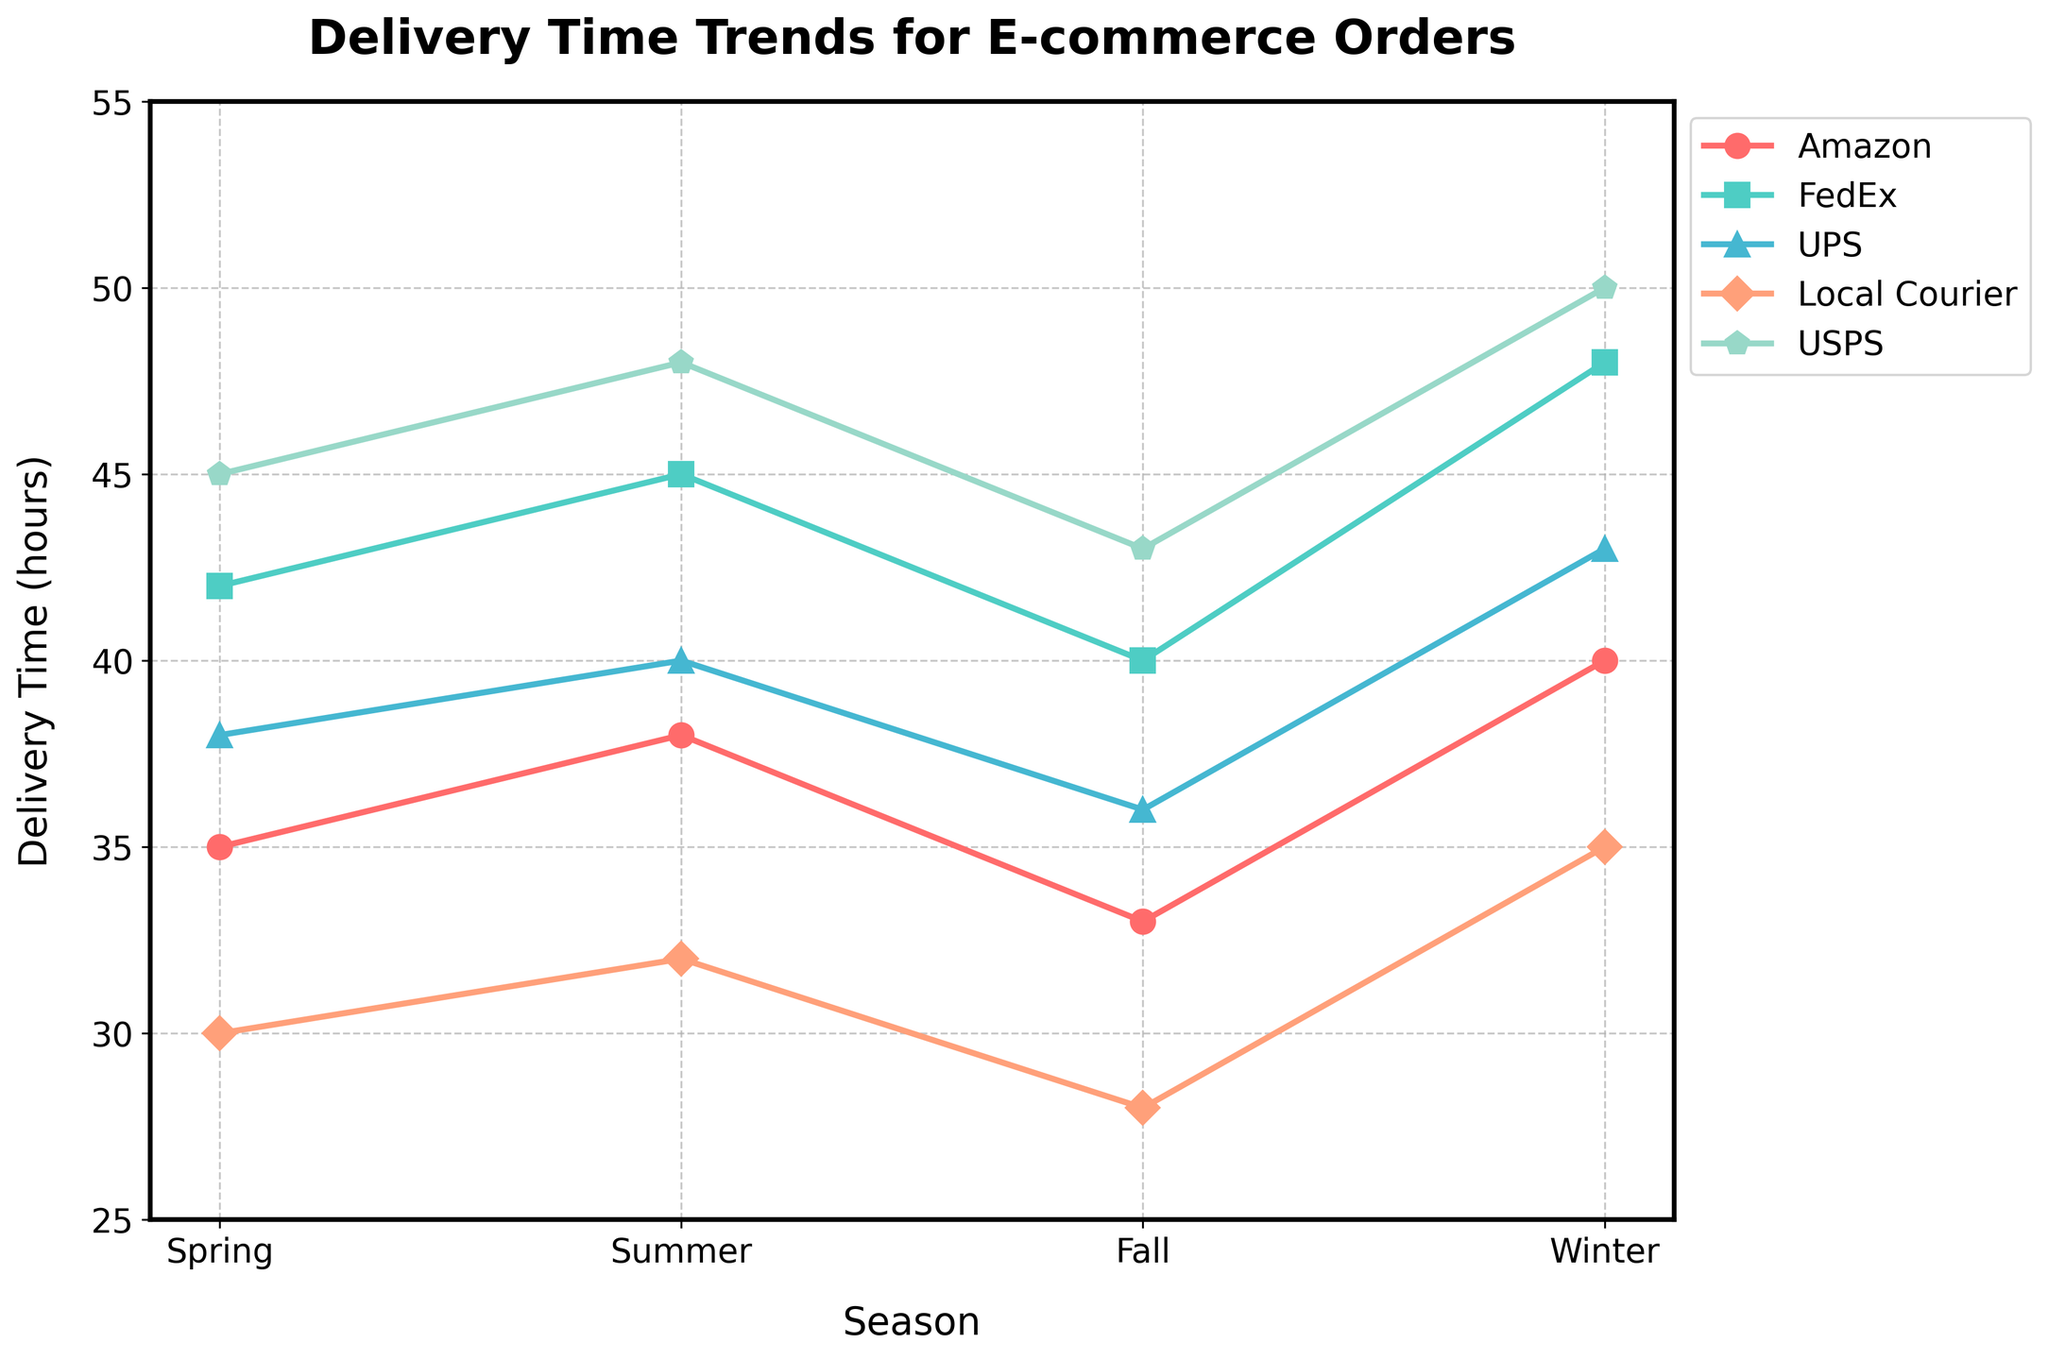What is the average delivery time for Amazon across all seasons? To calculate the average, add the delivery times for Amazon in each season: Spring (35), Summer (38), Fall (33), and Winter (40). Total sum = 35 + 38 + 33 + 40 = 146. Divide by the number of seasons (4). Average = 146 / 4
Answer: 36.5 Which courier service has the longest delivery time in Winter? In Winter, the delivery times are: Amazon (40), FedEx (48), UPS (43), Local Courier (35), USPS (50). The longest is USPS at 50 hours.
Answer: USPS During which season is the delivery time for Local Courier the shortest? The delivery times for Local Courier are: Spring (30), Summer (32), Fall (28), Winter (35). The shortest time is in Fall.
Answer: Fall What is the difference in delivery time between UPS and FedEx in Summer? In Summer, UPS has a delivery time of 40 hours and FedEx has a delivery time of 45 hours. The difference is 45 - 40 = 5 hours.
Answer: 5 How does the average delivery time in Winter compare to that in Fall? Calculate the average delivery time for all couriers in Winter and Fall. In Winter: (40 + 48 + 43 + 35 + 50) / 5 = 43.2 hours. In Fall: (33 + 40 + 36 + 28 + 43) / 5 = 36 hours. Winter average is higher than Fall.
Answer: Winter > Fall Which courier company has the most consistent delivery times across all seasons? Look at the variations in delivery times for each company: Amazon (35, 38, 33, 40), FedEx (42, 45, 40, 48), UPS (38, 40, 36, 43), Local Courier (30, 32, 28, 35), USPS (45, 48, 43, 50). Local Courier has the smallest range (7).
Answer: Local Courier What is the overall range of delivery times for USPS across all seasons? Check USPS delivery times: Spring (45), Summer (48), Fall (43), Winter (50). The range is max - min = 50 - 43 = 7 hours.
Answer: 7 Identify the season and company with the shortest overall delivery time. Assess the delivery times: Spring (Local Courier, 30), Summer (Local Courier, 32), Fall (Local Courier, 28), Winter (Local Courier, 35). The shortest is Local Courier in Fall at 28 hours.
Answer: Local Courier, Fall How does FedEx's delivery time in Spring compare to UPS's in Spring? In Spring, FedEx's delivery time is 42 hours, and UPS's is 38 hours. FedEx takes 4 hours longer than UPS.
Answer: FedEx > UPS by 4 hours 